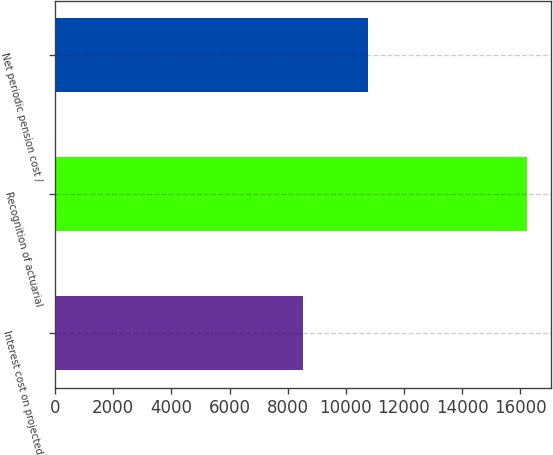<chart> <loc_0><loc_0><loc_500><loc_500><bar_chart><fcel>Interest cost on projected<fcel>Recognition of actuarial<fcel>Net periodic pension cost /<nl><fcel>8511<fcel>16247<fcel>10750<nl></chart> 